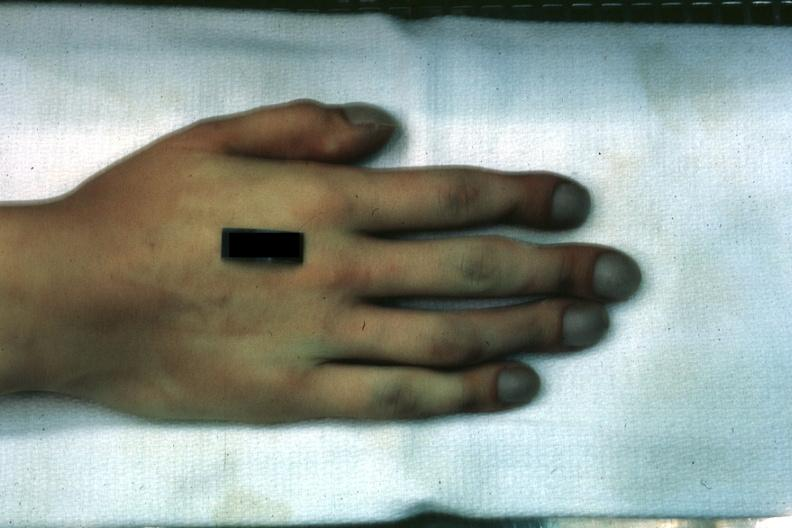s foot present?
Answer the question using a single word or phrase. No 